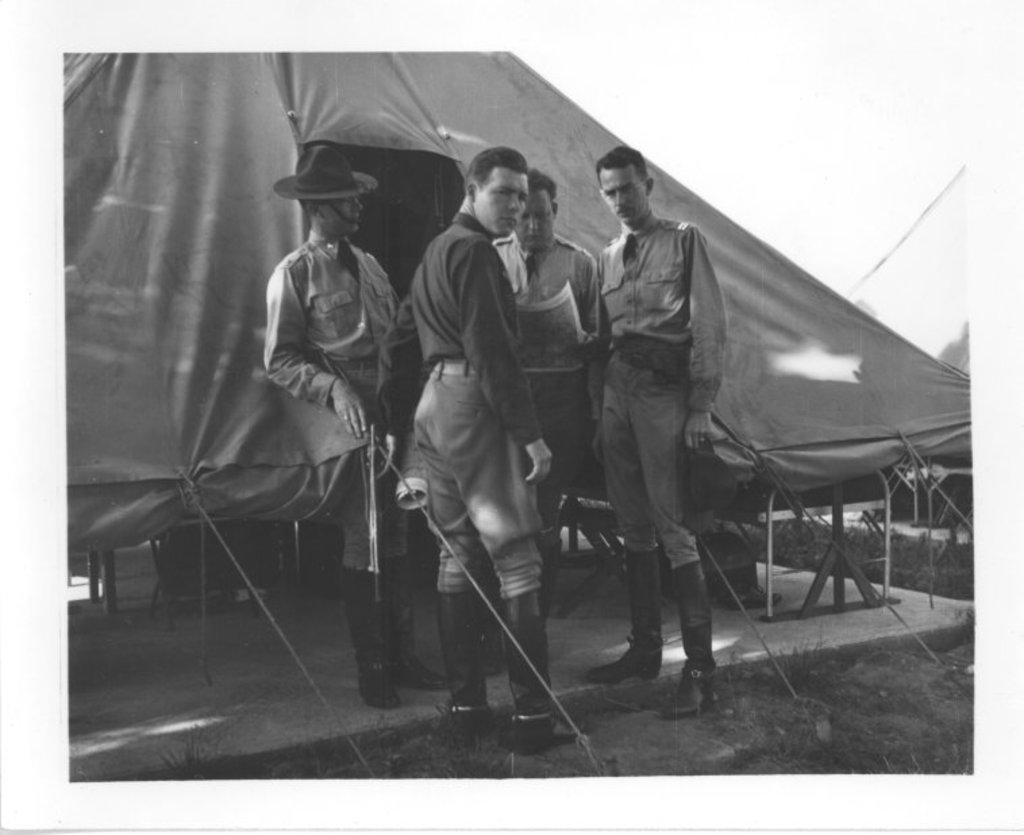Who or what can be seen in the image? There are people in the image. What type of terrain is visible in the image? There is grass in the image. What type of shelter is present in the image? There is a tent in the image. What is visible at the top of the image? The sky is visible at the top of the image. How many ears can be seen on the people in the image? It is impossible to determine the number of ears on the people in the image without seeing their faces. --- Facts: 1. There is a car in the image. 2. The car is red. 3. There are people in the car. 4. The car has four wheels. 5. The car has a license plate. Absurd Topics: bird, flower, mountain Conversation: What is the main subject of the image? The main subject of the image is a car. What color is the car? The car is red. Are there any passengers in the car? Yes, there are people in the car. How many wheels does the car have? The car has four wheels. Is there any identifying information on the car? Yes, the car has a license plate. Reasoning: Let's think step by step in order to produce the conversation. We start by identifying the main subject in the image, which is the car. Then, we expand the conversation to include other details about the car, such as its color, the presence of passengers, the number of wheels, and the license plate. Each question is designed to elicit a specific detail about the image that is known from the provided facts. Absurd Question/Answer: Can you see any flowers growing near the car in the image? There is no mention of flowers in the image; it only features a red car with people inside. 